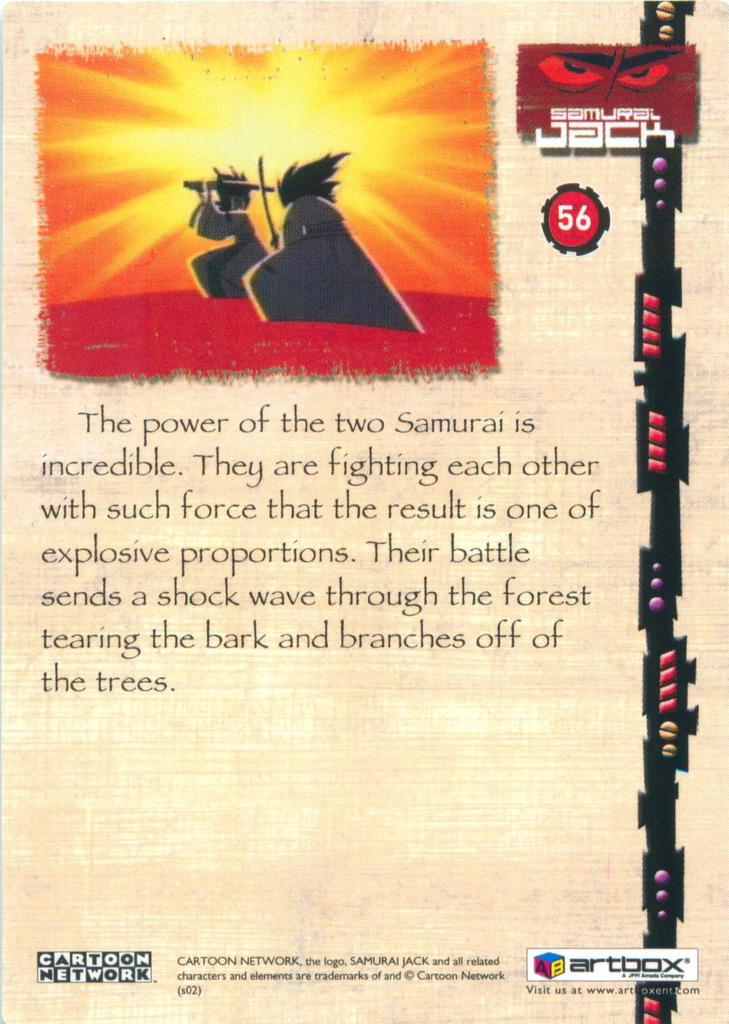Provide a one-sentence caption for the provided image. Two Samurai cartoon characters from the Samurai Jack series on Cartoon Network are shown along with information on this poster. 